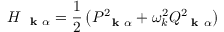<formula> <loc_0><loc_0><loc_500><loc_500>H _ { k \alpha } = \frac { 1 } { 2 } \left ( P _ { k \alpha } ^ { 2 } + \omega _ { k } ^ { 2 } Q _ { k \alpha } ^ { 2 } \right )</formula> 